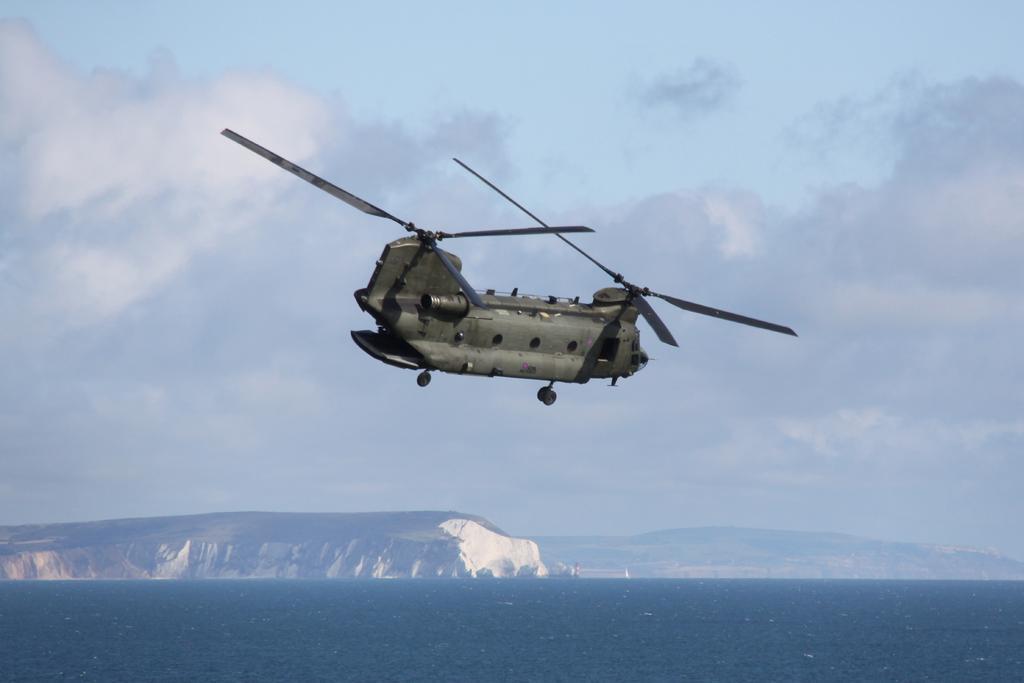Describe this image in one or two sentences. In this image there is a Chinook helicopter in the air. At the bottom of the image there is a river. In the background there are mountains and the sky. 